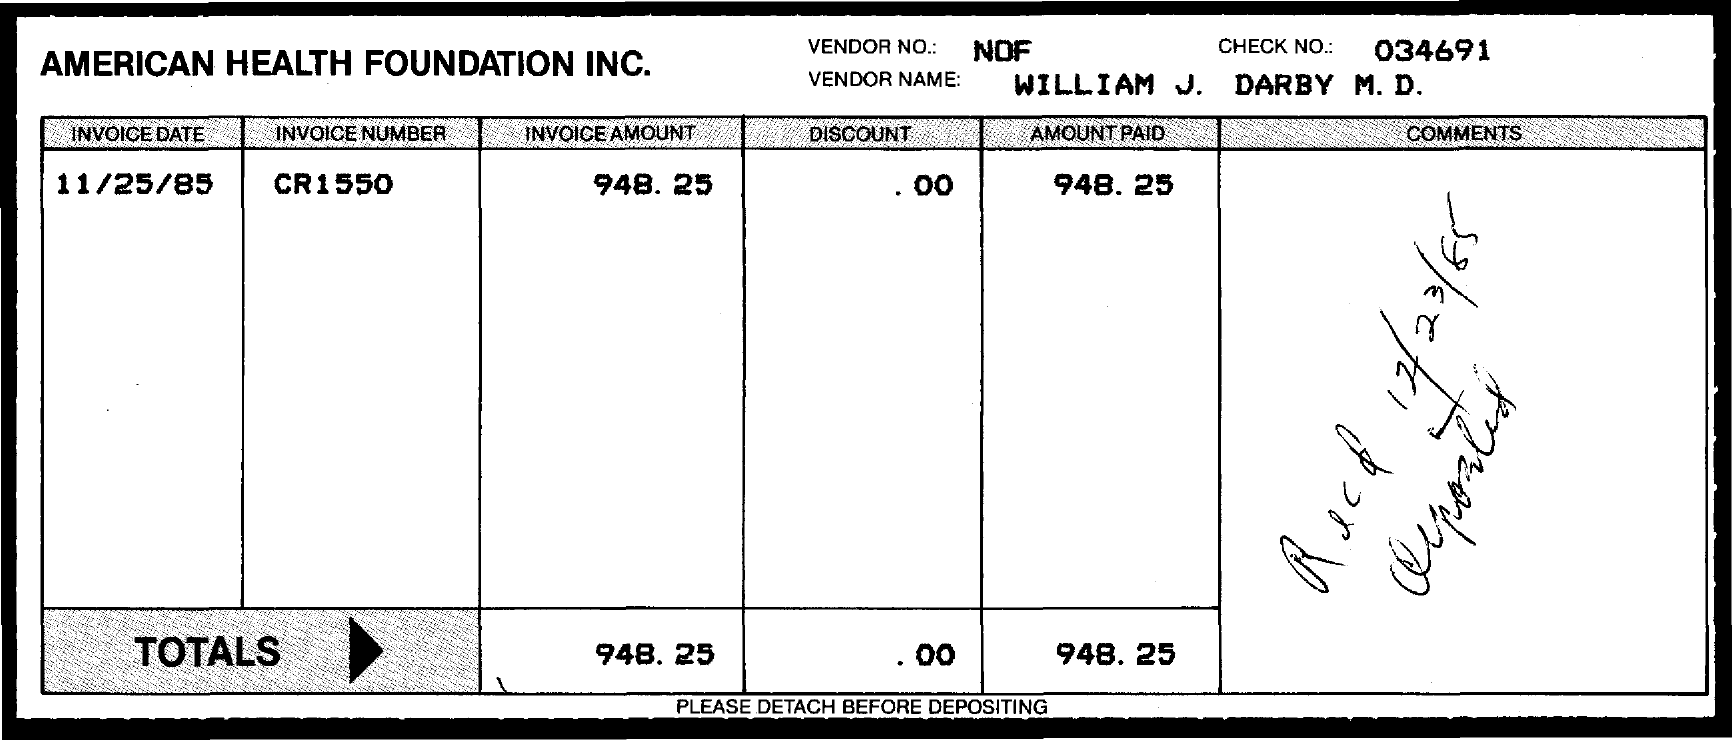Point out several critical features in this image. The invoice amount indicated in the document is 948.25... The given invoice belongs to a company named American Health Foundation Inc. The vendor number provided on the invoice is nof.. The received date of the invoice is December 23, 1985. The check number mentioned in the invoice is 034691... 